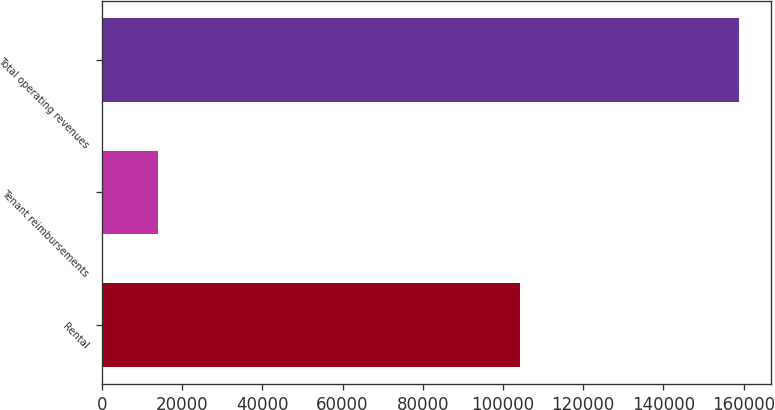Convert chart to OTSL. <chart><loc_0><loc_0><loc_500><loc_500><bar_chart><fcel>Rental<fcel>Tenant reimbursements<fcel>Total operating revenues<nl><fcel>104199<fcel>13962<fcel>158920<nl></chart> 